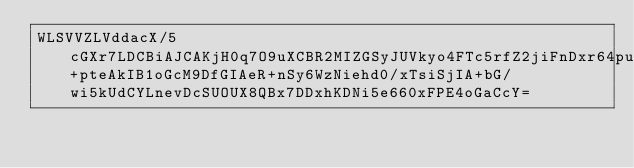Convert code to text. <code><loc_0><loc_0><loc_500><loc_500><_SML_>WLSVVZLVddacX/5cGXr7LDCBiAJCAKjH0q7O9uXCBR2MIZGSyJUVkyo4FTc5rfZ2jiFnDxr64puBHw4yxKYaOWAlHmfZYHDyCERjmEbZA7yvOEPh+pteAkIB1oGcM9DfGIAeR+nSy6WzNiehd0/xTsiSjIA+bG/wi5kUdCYLnevDcSUOUX8QBx7DDxhKDNi5e660xFPE4oGaCcY=</code> 